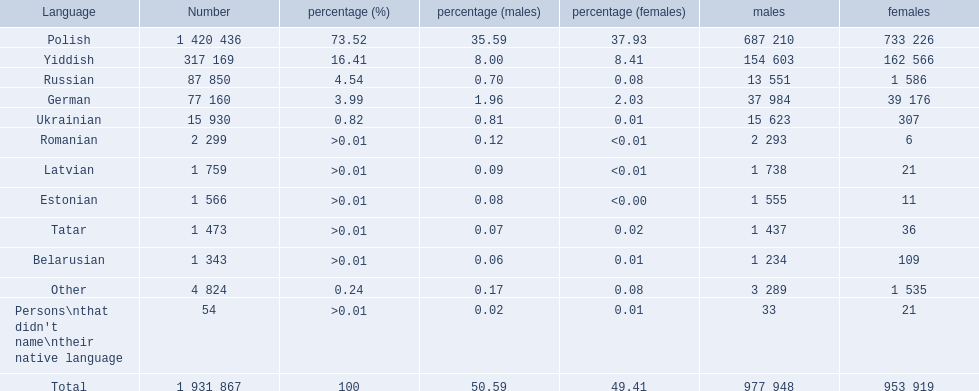What are all the languages? Polish, Yiddish, Russian, German, Ukrainian, Romanian, Latvian, Estonian, Tatar, Belarusian, Other, Persons\nthat didn't name\ntheir native language. Of those languages, which five had fewer than 50 females speaking it? 6, 21, 11, 36, 21. Of those five languages, which is the lowest? Romanian. 